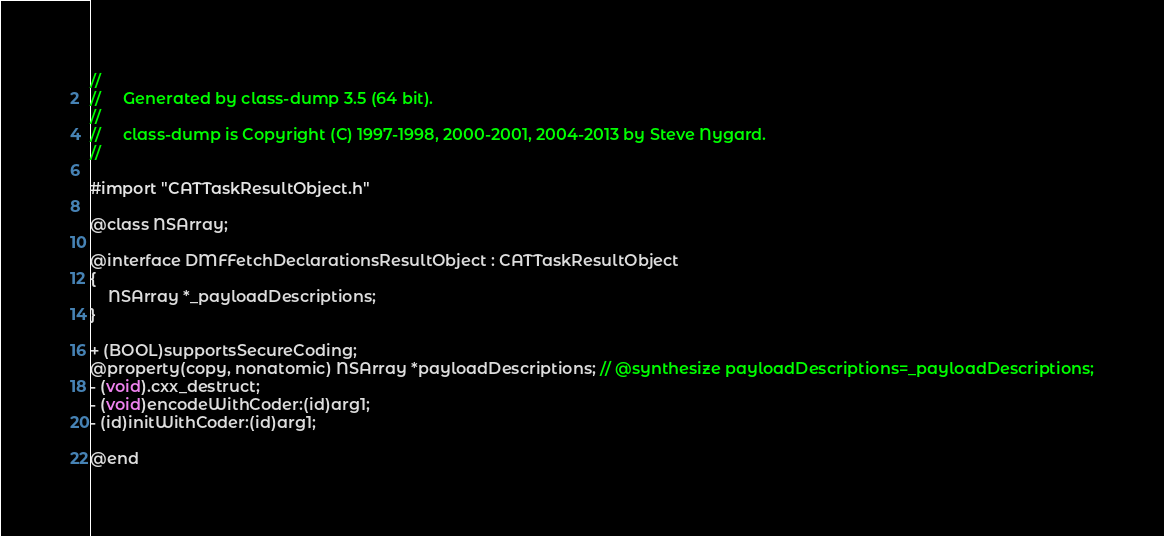Convert code to text. <code><loc_0><loc_0><loc_500><loc_500><_C_>//
//     Generated by class-dump 3.5 (64 bit).
//
//     class-dump is Copyright (C) 1997-1998, 2000-2001, 2004-2013 by Steve Nygard.
//

#import "CATTaskResultObject.h"

@class NSArray;

@interface DMFFetchDeclarationsResultObject : CATTaskResultObject
{
    NSArray *_payloadDescriptions;
}

+ (BOOL)supportsSecureCoding;
@property(copy, nonatomic) NSArray *payloadDescriptions; // @synthesize payloadDescriptions=_payloadDescriptions;
- (void).cxx_destruct;
- (void)encodeWithCoder:(id)arg1;
- (id)initWithCoder:(id)arg1;

@end

</code> 